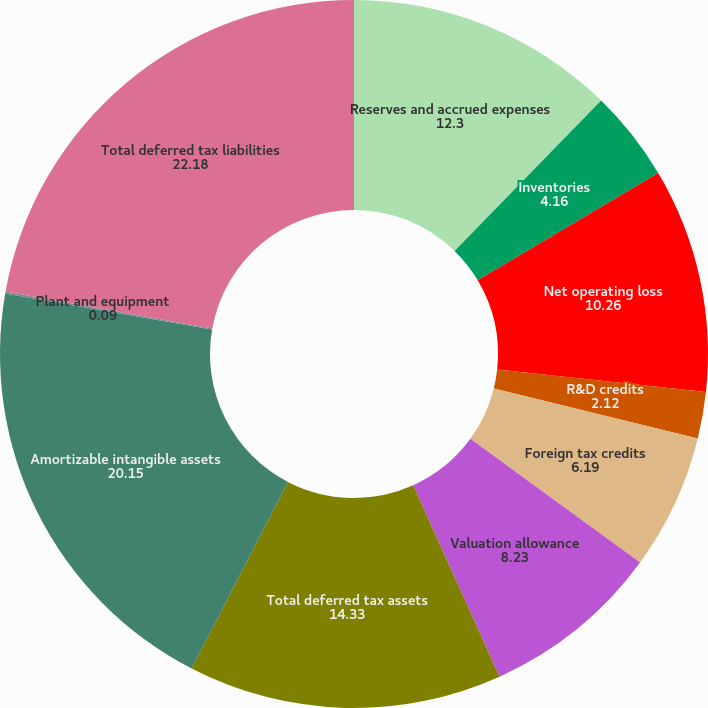Convert chart. <chart><loc_0><loc_0><loc_500><loc_500><pie_chart><fcel>Reserves and accrued expenses<fcel>Inventories<fcel>Net operating loss<fcel>R&D credits<fcel>Foreign tax credits<fcel>Valuation allowance<fcel>Total deferred tax assets<fcel>Amortizable intangible assets<fcel>Plant and equipment<fcel>Total deferred tax liabilities<nl><fcel>12.3%<fcel>4.16%<fcel>10.26%<fcel>2.12%<fcel>6.19%<fcel>8.23%<fcel>14.33%<fcel>20.15%<fcel>0.09%<fcel>22.18%<nl></chart> 